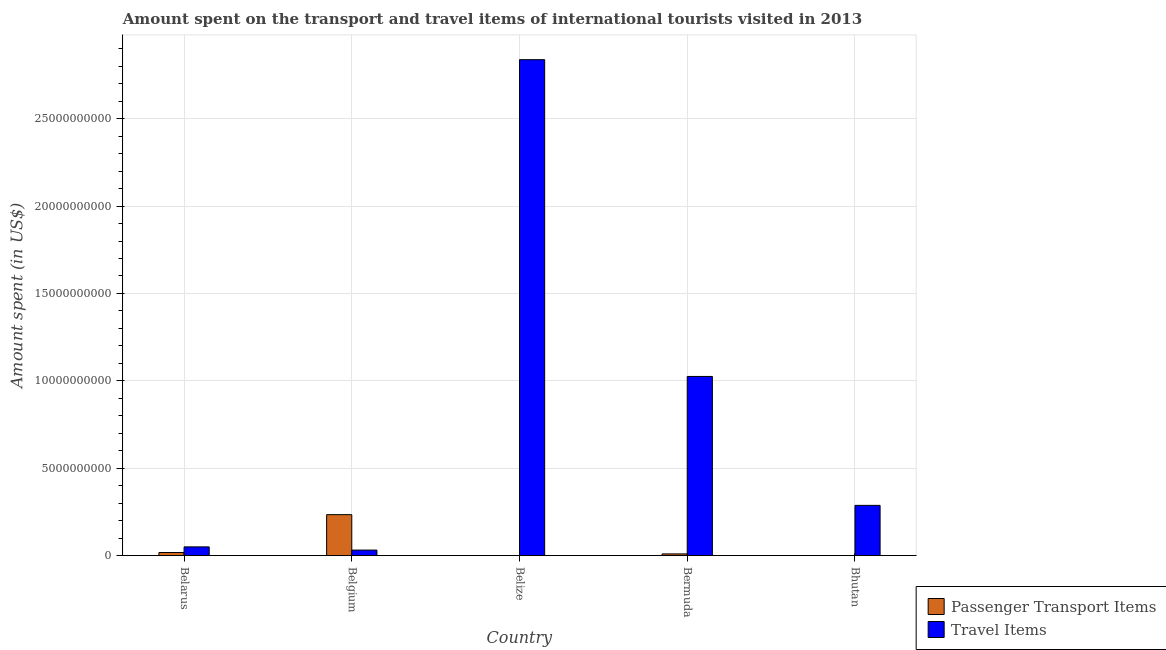How many different coloured bars are there?
Your answer should be compact. 2. Are the number of bars per tick equal to the number of legend labels?
Your answer should be compact. Yes. How many bars are there on the 1st tick from the left?
Provide a short and direct response. 2. What is the label of the 1st group of bars from the left?
Your response must be concise. Belarus. In how many cases, is the number of bars for a given country not equal to the number of legend labels?
Provide a succinct answer. 0. Across all countries, what is the maximum amount spent on passenger transport items?
Provide a short and direct response. 2.35e+09. Across all countries, what is the minimum amount spent in travel items?
Your answer should be compact. 3.19e+08. In which country was the amount spent on passenger transport items maximum?
Ensure brevity in your answer.  Belgium. In which country was the amount spent on passenger transport items minimum?
Provide a short and direct response. Belize. What is the total amount spent in travel items in the graph?
Keep it short and to the point. 4.23e+1. What is the difference between the amount spent on passenger transport items in Bermuda and that in Bhutan?
Provide a short and direct response. 9.70e+07. What is the difference between the amount spent on passenger transport items in Bermuda and the amount spent in travel items in Bhutan?
Keep it short and to the point. -2.78e+09. What is the average amount spent on passenger transport items per country?
Your answer should be compact. 5.26e+08. What is the difference between the amount spent on passenger transport items and amount spent in travel items in Bermuda?
Provide a short and direct response. -1.02e+1. In how many countries, is the amount spent on passenger transport items greater than 6000000000 US$?
Provide a short and direct response. 0. What is the ratio of the amount spent on passenger transport items in Belize to that in Bhutan?
Ensure brevity in your answer.  0.67. Is the amount spent on passenger transport items in Belarus less than that in Belgium?
Your answer should be compact. Yes. Is the difference between the amount spent in travel items in Belize and Bermuda greater than the difference between the amount spent on passenger transport items in Belize and Bermuda?
Give a very brief answer. Yes. What is the difference between the highest and the second highest amount spent on passenger transport items?
Offer a terse response. 2.17e+09. What is the difference between the highest and the lowest amount spent in travel items?
Your response must be concise. 2.81e+1. In how many countries, is the amount spent in travel items greater than the average amount spent in travel items taken over all countries?
Provide a short and direct response. 2. Is the sum of the amount spent in travel items in Belarus and Belgium greater than the maximum amount spent on passenger transport items across all countries?
Give a very brief answer. No. What does the 1st bar from the left in Bermuda represents?
Your answer should be very brief. Passenger Transport Items. What does the 1st bar from the right in Bhutan represents?
Offer a terse response. Travel Items. Are all the bars in the graph horizontal?
Your response must be concise. No. Does the graph contain grids?
Offer a very short reply. Yes. How many legend labels are there?
Provide a succinct answer. 2. What is the title of the graph?
Make the answer very short. Amount spent on the transport and travel items of international tourists visited in 2013. Does "Number of arrivals" appear as one of the legend labels in the graph?
Offer a terse response. No. What is the label or title of the Y-axis?
Your answer should be very brief. Amount spent (in US$). What is the Amount spent (in US$) in Passenger Transport Items in Belarus?
Ensure brevity in your answer.  1.80e+08. What is the Amount spent (in US$) in Travel Items in Belarus?
Your response must be concise. 5.02e+08. What is the Amount spent (in US$) in Passenger Transport Items in Belgium?
Ensure brevity in your answer.  2.35e+09. What is the Amount spent (in US$) in Travel Items in Belgium?
Offer a terse response. 3.19e+08. What is the Amount spent (in US$) of Passenger Transport Items in Belize?
Provide a short and direct response. 2.00e+06. What is the Amount spent (in US$) of Travel Items in Belize?
Provide a succinct answer. 2.84e+1. What is the Amount spent (in US$) in Passenger Transport Items in Bermuda?
Your answer should be compact. 1.00e+08. What is the Amount spent (in US$) of Travel Items in Bermuda?
Your response must be concise. 1.03e+1. What is the Amount spent (in US$) of Passenger Transport Items in Bhutan?
Your answer should be compact. 3.00e+06. What is the Amount spent (in US$) of Travel Items in Bhutan?
Ensure brevity in your answer.  2.88e+09. Across all countries, what is the maximum Amount spent (in US$) in Passenger Transport Items?
Keep it short and to the point. 2.35e+09. Across all countries, what is the maximum Amount spent (in US$) of Travel Items?
Provide a succinct answer. 2.84e+1. Across all countries, what is the minimum Amount spent (in US$) in Travel Items?
Give a very brief answer. 3.19e+08. What is the total Amount spent (in US$) in Passenger Transport Items in the graph?
Your answer should be very brief. 2.63e+09. What is the total Amount spent (in US$) in Travel Items in the graph?
Keep it short and to the point. 4.23e+1. What is the difference between the Amount spent (in US$) in Passenger Transport Items in Belarus and that in Belgium?
Keep it short and to the point. -2.17e+09. What is the difference between the Amount spent (in US$) of Travel Items in Belarus and that in Belgium?
Offer a very short reply. 1.83e+08. What is the difference between the Amount spent (in US$) in Passenger Transport Items in Belarus and that in Belize?
Offer a very short reply. 1.78e+08. What is the difference between the Amount spent (in US$) of Travel Items in Belarus and that in Belize?
Make the answer very short. -2.79e+1. What is the difference between the Amount spent (in US$) of Passenger Transport Items in Belarus and that in Bermuda?
Ensure brevity in your answer.  8.00e+07. What is the difference between the Amount spent (in US$) of Travel Items in Belarus and that in Bermuda?
Provide a short and direct response. -9.75e+09. What is the difference between the Amount spent (in US$) of Passenger Transport Items in Belarus and that in Bhutan?
Offer a very short reply. 1.77e+08. What is the difference between the Amount spent (in US$) in Travel Items in Belarus and that in Bhutan?
Provide a succinct answer. -2.38e+09. What is the difference between the Amount spent (in US$) of Passenger Transport Items in Belgium and that in Belize?
Offer a terse response. 2.34e+09. What is the difference between the Amount spent (in US$) in Travel Items in Belgium and that in Belize?
Provide a short and direct response. -2.81e+1. What is the difference between the Amount spent (in US$) of Passenger Transport Items in Belgium and that in Bermuda?
Give a very brief answer. 2.25e+09. What is the difference between the Amount spent (in US$) in Travel Items in Belgium and that in Bermuda?
Your answer should be very brief. -9.93e+09. What is the difference between the Amount spent (in US$) in Passenger Transport Items in Belgium and that in Bhutan?
Offer a very short reply. 2.34e+09. What is the difference between the Amount spent (in US$) of Travel Items in Belgium and that in Bhutan?
Your answer should be compact. -2.56e+09. What is the difference between the Amount spent (in US$) in Passenger Transport Items in Belize and that in Bermuda?
Offer a terse response. -9.80e+07. What is the difference between the Amount spent (in US$) in Travel Items in Belize and that in Bermuda?
Your answer should be very brief. 1.81e+1. What is the difference between the Amount spent (in US$) in Travel Items in Belize and that in Bhutan?
Offer a terse response. 2.55e+1. What is the difference between the Amount spent (in US$) in Passenger Transport Items in Bermuda and that in Bhutan?
Give a very brief answer. 9.70e+07. What is the difference between the Amount spent (in US$) of Travel Items in Bermuda and that in Bhutan?
Offer a terse response. 7.38e+09. What is the difference between the Amount spent (in US$) in Passenger Transport Items in Belarus and the Amount spent (in US$) in Travel Items in Belgium?
Your answer should be compact. -1.39e+08. What is the difference between the Amount spent (in US$) in Passenger Transport Items in Belarus and the Amount spent (in US$) in Travel Items in Belize?
Your answer should be compact. -2.82e+1. What is the difference between the Amount spent (in US$) of Passenger Transport Items in Belarus and the Amount spent (in US$) of Travel Items in Bermuda?
Provide a succinct answer. -1.01e+1. What is the difference between the Amount spent (in US$) in Passenger Transport Items in Belarus and the Amount spent (in US$) in Travel Items in Bhutan?
Offer a terse response. -2.70e+09. What is the difference between the Amount spent (in US$) in Passenger Transport Items in Belgium and the Amount spent (in US$) in Travel Items in Belize?
Your answer should be very brief. -2.60e+1. What is the difference between the Amount spent (in US$) in Passenger Transport Items in Belgium and the Amount spent (in US$) in Travel Items in Bermuda?
Your answer should be compact. -7.91e+09. What is the difference between the Amount spent (in US$) of Passenger Transport Items in Belgium and the Amount spent (in US$) of Travel Items in Bhutan?
Make the answer very short. -5.31e+08. What is the difference between the Amount spent (in US$) in Passenger Transport Items in Belize and the Amount spent (in US$) in Travel Items in Bermuda?
Make the answer very short. -1.03e+1. What is the difference between the Amount spent (in US$) of Passenger Transport Items in Belize and the Amount spent (in US$) of Travel Items in Bhutan?
Provide a succinct answer. -2.88e+09. What is the difference between the Amount spent (in US$) of Passenger Transport Items in Bermuda and the Amount spent (in US$) of Travel Items in Bhutan?
Give a very brief answer. -2.78e+09. What is the average Amount spent (in US$) in Passenger Transport Items per country?
Your answer should be very brief. 5.26e+08. What is the average Amount spent (in US$) in Travel Items per country?
Make the answer very short. 8.47e+09. What is the difference between the Amount spent (in US$) of Passenger Transport Items and Amount spent (in US$) of Travel Items in Belarus?
Make the answer very short. -3.22e+08. What is the difference between the Amount spent (in US$) of Passenger Transport Items and Amount spent (in US$) of Travel Items in Belgium?
Offer a very short reply. 2.03e+09. What is the difference between the Amount spent (in US$) in Passenger Transport Items and Amount spent (in US$) in Travel Items in Belize?
Keep it short and to the point. -2.84e+1. What is the difference between the Amount spent (in US$) in Passenger Transport Items and Amount spent (in US$) in Travel Items in Bermuda?
Offer a terse response. -1.02e+1. What is the difference between the Amount spent (in US$) in Passenger Transport Items and Amount spent (in US$) in Travel Items in Bhutan?
Your response must be concise. -2.87e+09. What is the ratio of the Amount spent (in US$) of Passenger Transport Items in Belarus to that in Belgium?
Offer a very short reply. 0.08. What is the ratio of the Amount spent (in US$) in Travel Items in Belarus to that in Belgium?
Your answer should be compact. 1.57. What is the ratio of the Amount spent (in US$) in Travel Items in Belarus to that in Belize?
Your answer should be compact. 0.02. What is the ratio of the Amount spent (in US$) in Passenger Transport Items in Belarus to that in Bermuda?
Keep it short and to the point. 1.8. What is the ratio of the Amount spent (in US$) in Travel Items in Belarus to that in Bermuda?
Offer a terse response. 0.05. What is the ratio of the Amount spent (in US$) of Passenger Transport Items in Belarus to that in Bhutan?
Offer a terse response. 60. What is the ratio of the Amount spent (in US$) of Travel Items in Belarus to that in Bhutan?
Ensure brevity in your answer.  0.17. What is the ratio of the Amount spent (in US$) in Passenger Transport Items in Belgium to that in Belize?
Offer a very short reply. 1173. What is the ratio of the Amount spent (in US$) in Travel Items in Belgium to that in Belize?
Offer a very short reply. 0.01. What is the ratio of the Amount spent (in US$) of Passenger Transport Items in Belgium to that in Bermuda?
Provide a short and direct response. 23.46. What is the ratio of the Amount spent (in US$) of Travel Items in Belgium to that in Bermuda?
Ensure brevity in your answer.  0.03. What is the ratio of the Amount spent (in US$) in Passenger Transport Items in Belgium to that in Bhutan?
Keep it short and to the point. 782. What is the ratio of the Amount spent (in US$) of Travel Items in Belgium to that in Bhutan?
Ensure brevity in your answer.  0.11. What is the ratio of the Amount spent (in US$) in Passenger Transport Items in Belize to that in Bermuda?
Your answer should be very brief. 0.02. What is the ratio of the Amount spent (in US$) in Travel Items in Belize to that in Bermuda?
Make the answer very short. 2.77. What is the ratio of the Amount spent (in US$) of Travel Items in Belize to that in Bhutan?
Your response must be concise. 9.86. What is the ratio of the Amount spent (in US$) in Passenger Transport Items in Bermuda to that in Bhutan?
Offer a terse response. 33.33. What is the ratio of the Amount spent (in US$) of Travel Items in Bermuda to that in Bhutan?
Your answer should be very brief. 3.56. What is the difference between the highest and the second highest Amount spent (in US$) of Passenger Transport Items?
Provide a short and direct response. 2.17e+09. What is the difference between the highest and the second highest Amount spent (in US$) in Travel Items?
Keep it short and to the point. 1.81e+1. What is the difference between the highest and the lowest Amount spent (in US$) of Passenger Transport Items?
Your answer should be very brief. 2.34e+09. What is the difference between the highest and the lowest Amount spent (in US$) in Travel Items?
Offer a very short reply. 2.81e+1. 